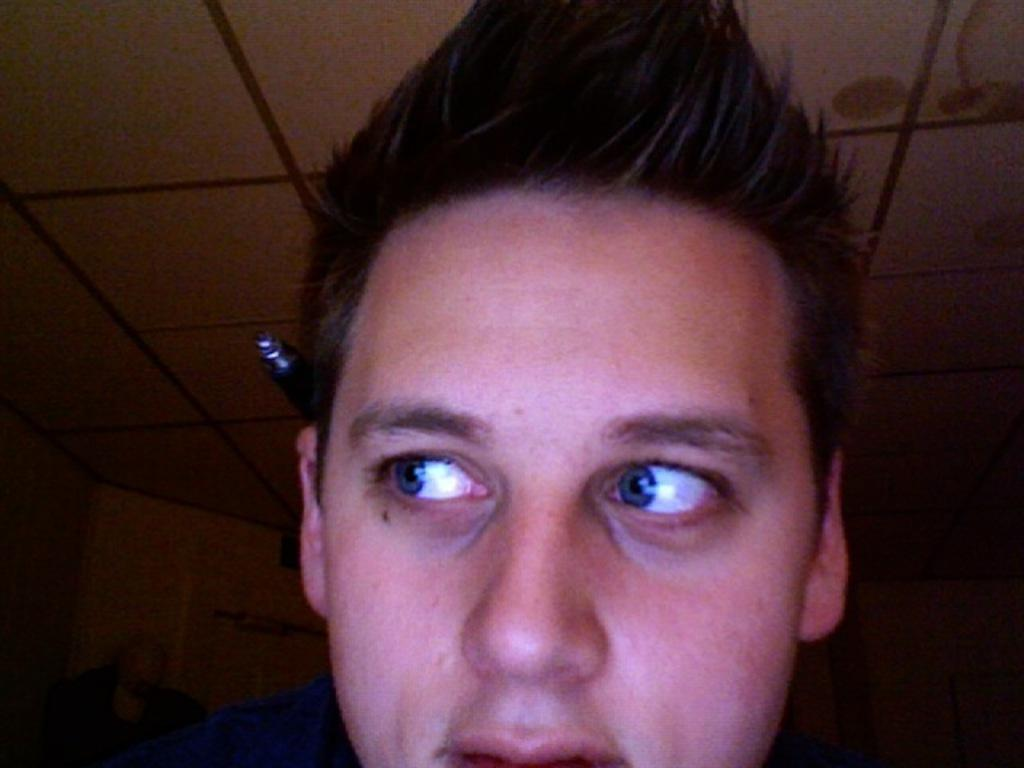What is the main subject of the image? There is a man in the image. Can you describe anything else visible in the image? There is an object visible in the background of the image. What type of care does the man provide to the discovery in the image? There is no discovery present in the image, and therefore no care is being provided. 